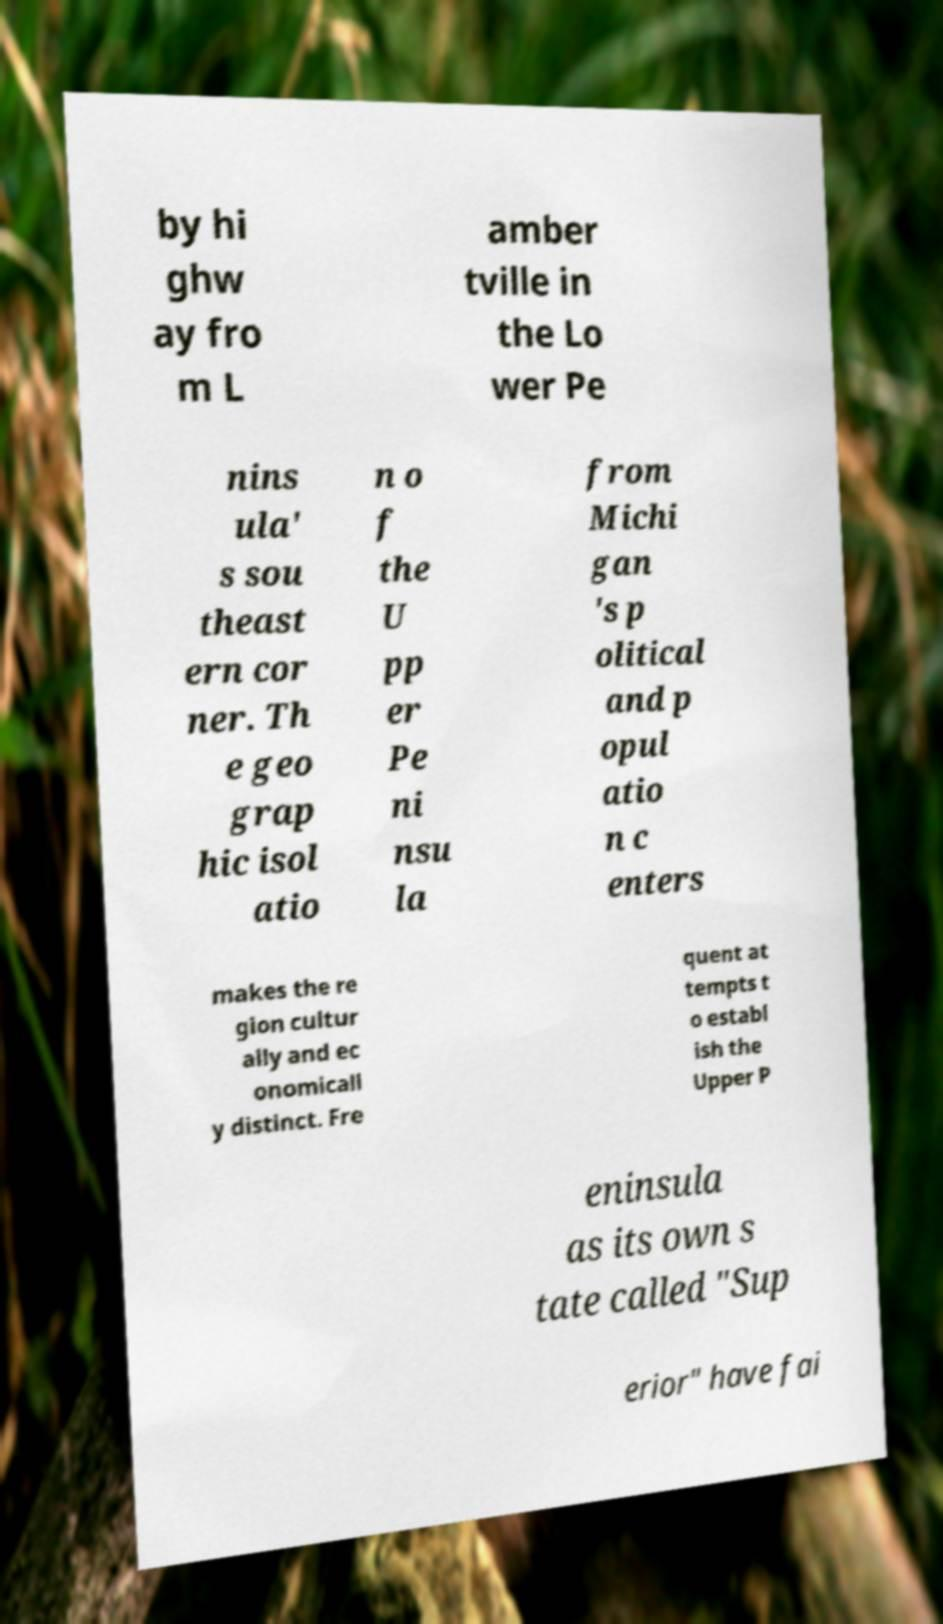Can you accurately transcribe the text from the provided image for me? by hi ghw ay fro m L amber tville in the Lo wer Pe nins ula' s sou theast ern cor ner. Th e geo grap hic isol atio n o f the U pp er Pe ni nsu la from Michi gan 's p olitical and p opul atio n c enters makes the re gion cultur ally and ec onomicall y distinct. Fre quent at tempts t o establ ish the Upper P eninsula as its own s tate called "Sup erior" have fai 